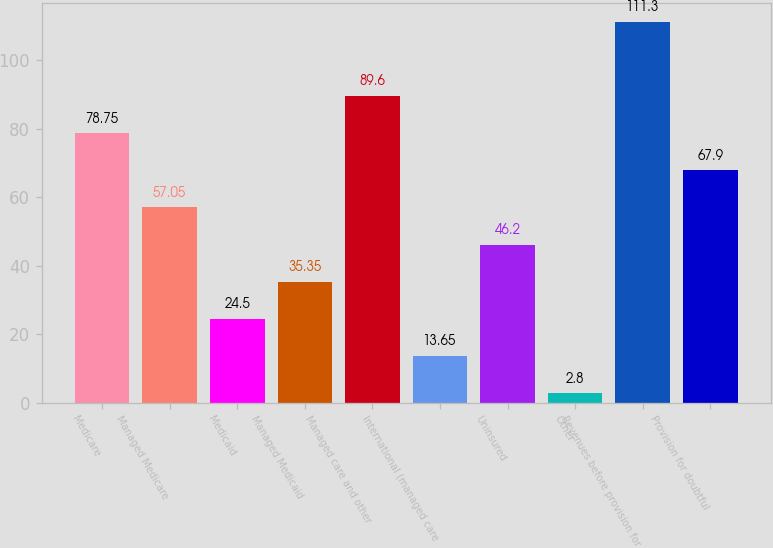<chart> <loc_0><loc_0><loc_500><loc_500><bar_chart><fcel>Medicare<fcel>Managed Medicare<fcel>Medicaid<fcel>Managed Medicaid<fcel>Managed care and other<fcel>International (managed care<fcel>Uninsured<fcel>Other<fcel>Revenues before provision for<fcel>Provision for doubtful<nl><fcel>78.75<fcel>57.05<fcel>24.5<fcel>35.35<fcel>89.6<fcel>13.65<fcel>46.2<fcel>2.8<fcel>111.3<fcel>67.9<nl></chart> 